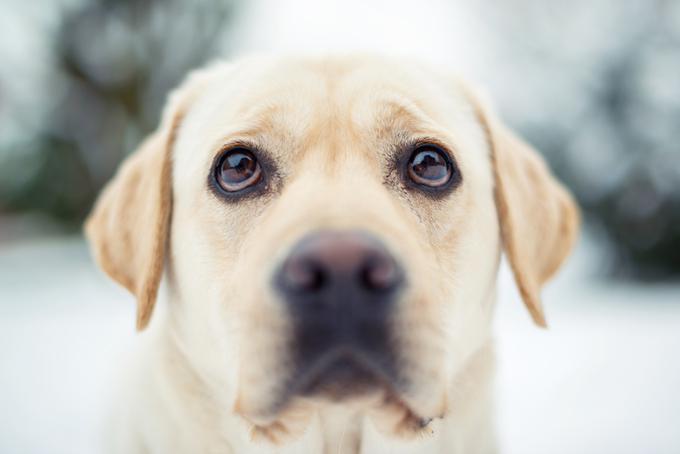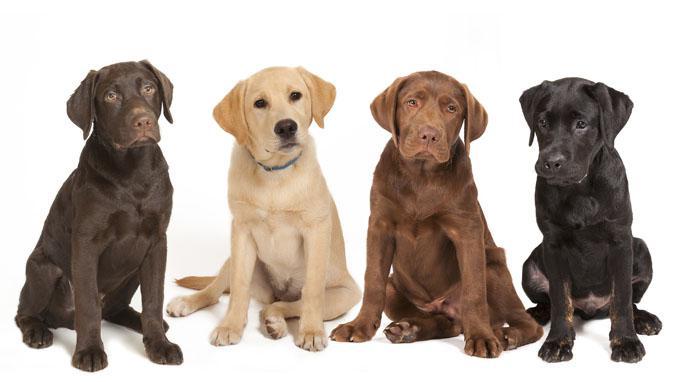The first image is the image on the left, the second image is the image on the right. Given the left and right images, does the statement "There are at least four dogs." hold true? Answer yes or no. Yes. 